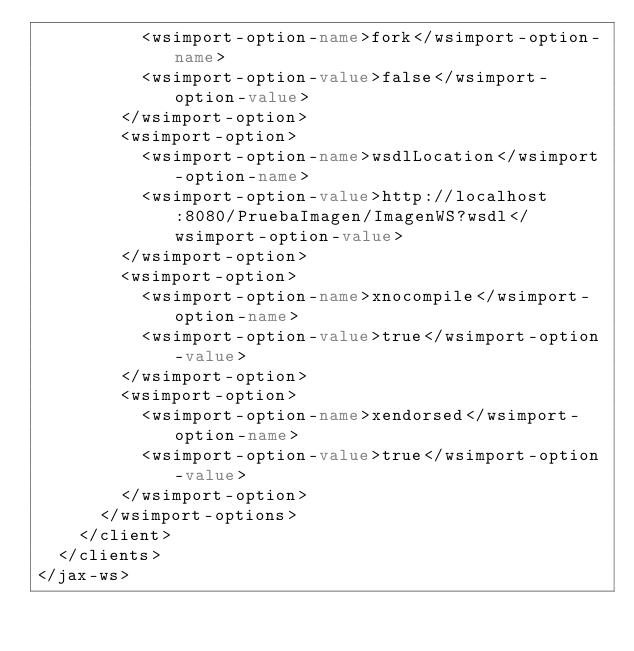Convert code to text. <code><loc_0><loc_0><loc_500><loc_500><_XML_>          <wsimport-option-name>fork</wsimport-option-name>
          <wsimport-option-value>false</wsimport-option-value>
        </wsimport-option>
        <wsimport-option>
          <wsimport-option-name>wsdlLocation</wsimport-option-name>
          <wsimport-option-value>http://localhost:8080/PruebaImagen/ImagenWS?wsdl</wsimport-option-value>
        </wsimport-option>
        <wsimport-option>
          <wsimport-option-name>xnocompile</wsimport-option-name>
          <wsimport-option-value>true</wsimport-option-value>
        </wsimport-option>
        <wsimport-option>
          <wsimport-option-name>xendorsed</wsimport-option-name>
          <wsimport-option-value>true</wsimport-option-value>
        </wsimport-option>
      </wsimport-options>
    </client>
  </clients>
</jax-ws>
</code> 